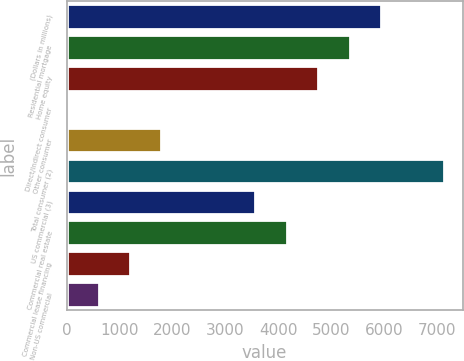Convert chart to OTSL. <chart><loc_0><loc_0><loc_500><loc_500><bar_chart><fcel>(Dollars in millions)<fcel>Residential mortgage<fcel>Home equity<fcel>Direct/Indirect consumer<fcel>Other consumer<fcel>Total consumer (2)<fcel>US commercial (3)<fcel>Commercial real estate<fcel>Commercial lease financing<fcel>Non-US commercial<nl><fcel>5948<fcel>5354<fcel>4760<fcel>8<fcel>1790<fcel>7136<fcel>3572<fcel>4166<fcel>1196<fcel>602<nl></chart> 